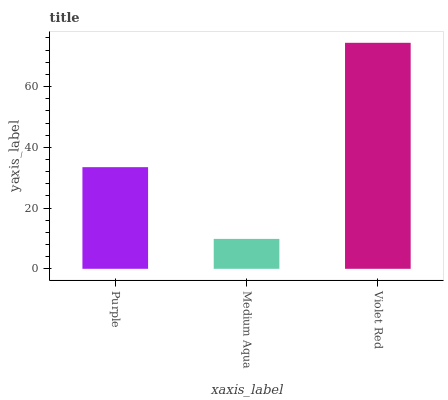Is Medium Aqua the minimum?
Answer yes or no. Yes. Is Violet Red the maximum?
Answer yes or no. Yes. Is Violet Red the minimum?
Answer yes or no. No. Is Medium Aqua the maximum?
Answer yes or no. No. Is Violet Red greater than Medium Aqua?
Answer yes or no. Yes. Is Medium Aqua less than Violet Red?
Answer yes or no. Yes. Is Medium Aqua greater than Violet Red?
Answer yes or no. No. Is Violet Red less than Medium Aqua?
Answer yes or no. No. Is Purple the high median?
Answer yes or no. Yes. Is Purple the low median?
Answer yes or no. Yes. Is Violet Red the high median?
Answer yes or no. No. Is Violet Red the low median?
Answer yes or no. No. 